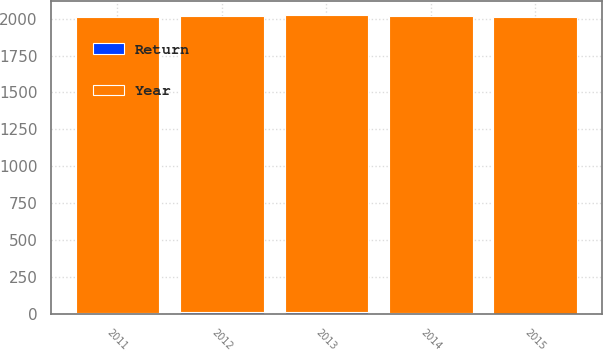Convert chart. <chart><loc_0><loc_0><loc_500><loc_500><stacked_bar_chart><ecel><fcel>2015<fcel>2014<fcel>2013<fcel>2012<fcel>2011<nl><fcel>Return<fcel>1.3<fcel>6.4<fcel>14.1<fcel>14.1<fcel>2.5<nl><fcel>Year<fcel>2010<fcel>2009<fcel>2008<fcel>2007<fcel>2006<nl></chart> 